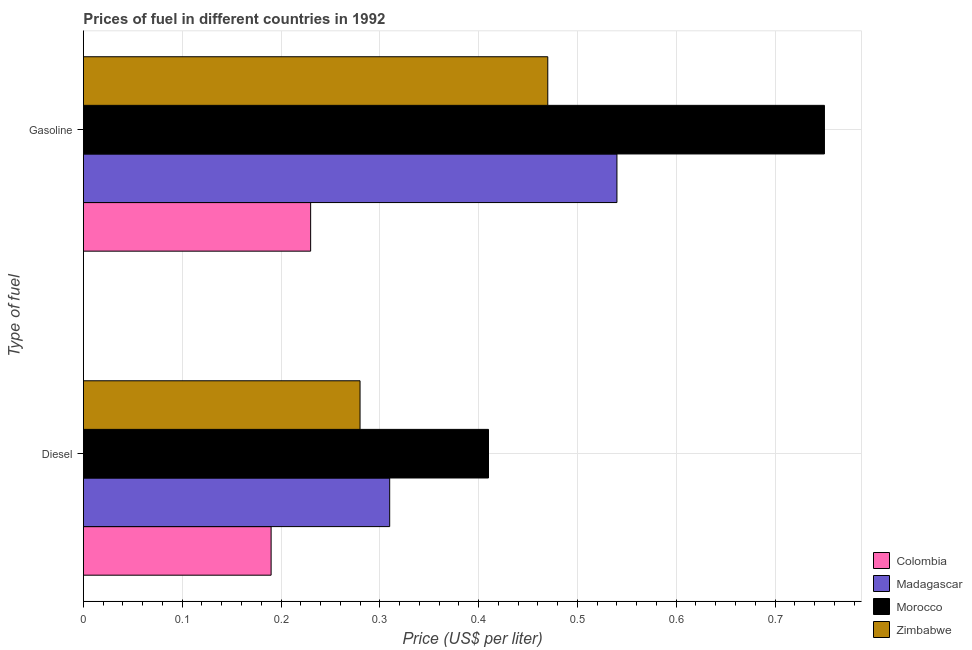How many different coloured bars are there?
Ensure brevity in your answer.  4. How many groups of bars are there?
Ensure brevity in your answer.  2. Are the number of bars per tick equal to the number of legend labels?
Your answer should be compact. Yes. Are the number of bars on each tick of the Y-axis equal?
Ensure brevity in your answer.  Yes. How many bars are there on the 2nd tick from the bottom?
Give a very brief answer. 4. What is the label of the 1st group of bars from the top?
Provide a short and direct response. Gasoline. What is the diesel price in Madagascar?
Provide a short and direct response. 0.31. Across all countries, what is the maximum diesel price?
Your response must be concise. 0.41. Across all countries, what is the minimum gasoline price?
Keep it short and to the point. 0.23. In which country was the gasoline price maximum?
Keep it short and to the point. Morocco. In which country was the diesel price minimum?
Provide a short and direct response. Colombia. What is the total diesel price in the graph?
Your response must be concise. 1.19. What is the difference between the diesel price in Zimbabwe and that in Colombia?
Offer a terse response. 0.09. What is the difference between the gasoline price in Zimbabwe and the diesel price in Madagascar?
Provide a succinct answer. 0.16. What is the average diesel price per country?
Provide a short and direct response. 0.3. What is the difference between the gasoline price and diesel price in Colombia?
Provide a succinct answer. 0.04. In how many countries, is the diesel price greater than 0.18 US$ per litre?
Ensure brevity in your answer.  4. What is the ratio of the diesel price in Colombia to that in Madagascar?
Keep it short and to the point. 0.61. Is the gasoline price in Madagascar less than that in Colombia?
Provide a short and direct response. No. What does the 3rd bar from the bottom in Diesel represents?
Ensure brevity in your answer.  Morocco. Are all the bars in the graph horizontal?
Provide a succinct answer. Yes. What is the difference between two consecutive major ticks on the X-axis?
Offer a very short reply. 0.1. Are the values on the major ticks of X-axis written in scientific E-notation?
Your answer should be very brief. No. Does the graph contain grids?
Offer a very short reply. Yes. What is the title of the graph?
Your response must be concise. Prices of fuel in different countries in 1992. Does "Togo" appear as one of the legend labels in the graph?
Your answer should be compact. No. What is the label or title of the X-axis?
Your answer should be very brief. Price (US$ per liter). What is the label or title of the Y-axis?
Your response must be concise. Type of fuel. What is the Price (US$ per liter) in Colombia in Diesel?
Keep it short and to the point. 0.19. What is the Price (US$ per liter) in Madagascar in Diesel?
Offer a very short reply. 0.31. What is the Price (US$ per liter) in Morocco in Diesel?
Give a very brief answer. 0.41. What is the Price (US$ per liter) in Zimbabwe in Diesel?
Make the answer very short. 0.28. What is the Price (US$ per liter) of Colombia in Gasoline?
Offer a terse response. 0.23. What is the Price (US$ per liter) of Madagascar in Gasoline?
Provide a succinct answer. 0.54. What is the Price (US$ per liter) in Morocco in Gasoline?
Offer a terse response. 0.75. What is the Price (US$ per liter) of Zimbabwe in Gasoline?
Offer a very short reply. 0.47. Across all Type of fuel, what is the maximum Price (US$ per liter) of Colombia?
Make the answer very short. 0.23. Across all Type of fuel, what is the maximum Price (US$ per liter) of Madagascar?
Your answer should be compact. 0.54. Across all Type of fuel, what is the maximum Price (US$ per liter) in Zimbabwe?
Offer a very short reply. 0.47. Across all Type of fuel, what is the minimum Price (US$ per liter) of Colombia?
Your answer should be compact. 0.19. Across all Type of fuel, what is the minimum Price (US$ per liter) of Madagascar?
Your answer should be very brief. 0.31. Across all Type of fuel, what is the minimum Price (US$ per liter) in Morocco?
Provide a succinct answer. 0.41. Across all Type of fuel, what is the minimum Price (US$ per liter) in Zimbabwe?
Your answer should be compact. 0.28. What is the total Price (US$ per liter) of Colombia in the graph?
Provide a succinct answer. 0.42. What is the total Price (US$ per liter) in Madagascar in the graph?
Give a very brief answer. 0.85. What is the total Price (US$ per liter) in Morocco in the graph?
Your answer should be very brief. 1.16. What is the difference between the Price (US$ per liter) of Colombia in Diesel and that in Gasoline?
Your answer should be compact. -0.04. What is the difference between the Price (US$ per liter) in Madagascar in Diesel and that in Gasoline?
Your response must be concise. -0.23. What is the difference between the Price (US$ per liter) of Morocco in Diesel and that in Gasoline?
Your response must be concise. -0.34. What is the difference between the Price (US$ per liter) of Zimbabwe in Diesel and that in Gasoline?
Provide a succinct answer. -0.19. What is the difference between the Price (US$ per liter) of Colombia in Diesel and the Price (US$ per liter) of Madagascar in Gasoline?
Your response must be concise. -0.35. What is the difference between the Price (US$ per liter) in Colombia in Diesel and the Price (US$ per liter) in Morocco in Gasoline?
Offer a terse response. -0.56. What is the difference between the Price (US$ per liter) of Colombia in Diesel and the Price (US$ per liter) of Zimbabwe in Gasoline?
Provide a succinct answer. -0.28. What is the difference between the Price (US$ per liter) in Madagascar in Diesel and the Price (US$ per liter) in Morocco in Gasoline?
Your response must be concise. -0.44. What is the difference between the Price (US$ per liter) of Madagascar in Diesel and the Price (US$ per liter) of Zimbabwe in Gasoline?
Offer a very short reply. -0.16. What is the difference between the Price (US$ per liter) of Morocco in Diesel and the Price (US$ per liter) of Zimbabwe in Gasoline?
Offer a very short reply. -0.06. What is the average Price (US$ per liter) of Colombia per Type of fuel?
Offer a very short reply. 0.21. What is the average Price (US$ per liter) of Madagascar per Type of fuel?
Keep it short and to the point. 0.42. What is the average Price (US$ per liter) of Morocco per Type of fuel?
Your answer should be compact. 0.58. What is the difference between the Price (US$ per liter) in Colombia and Price (US$ per liter) in Madagascar in Diesel?
Keep it short and to the point. -0.12. What is the difference between the Price (US$ per liter) in Colombia and Price (US$ per liter) in Morocco in Diesel?
Keep it short and to the point. -0.22. What is the difference between the Price (US$ per liter) of Colombia and Price (US$ per liter) of Zimbabwe in Diesel?
Give a very brief answer. -0.09. What is the difference between the Price (US$ per liter) of Madagascar and Price (US$ per liter) of Morocco in Diesel?
Provide a short and direct response. -0.1. What is the difference between the Price (US$ per liter) in Madagascar and Price (US$ per liter) in Zimbabwe in Diesel?
Make the answer very short. 0.03. What is the difference between the Price (US$ per liter) in Morocco and Price (US$ per liter) in Zimbabwe in Diesel?
Offer a very short reply. 0.13. What is the difference between the Price (US$ per liter) of Colombia and Price (US$ per liter) of Madagascar in Gasoline?
Ensure brevity in your answer.  -0.31. What is the difference between the Price (US$ per liter) of Colombia and Price (US$ per liter) of Morocco in Gasoline?
Provide a short and direct response. -0.52. What is the difference between the Price (US$ per liter) in Colombia and Price (US$ per liter) in Zimbabwe in Gasoline?
Provide a short and direct response. -0.24. What is the difference between the Price (US$ per liter) in Madagascar and Price (US$ per liter) in Morocco in Gasoline?
Your answer should be compact. -0.21. What is the difference between the Price (US$ per liter) in Madagascar and Price (US$ per liter) in Zimbabwe in Gasoline?
Provide a succinct answer. 0.07. What is the difference between the Price (US$ per liter) of Morocco and Price (US$ per liter) of Zimbabwe in Gasoline?
Your answer should be compact. 0.28. What is the ratio of the Price (US$ per liter) of Colombia in Diesel to that in Gasoline?
Offer a very short reply. 0.83. What is the ratio of the Price (US$ per liter) in Madagascar in Diesel to that in Gasoline?
Offer a very short reply. 0.57. What is the ratio of the Price (US$ per liter) of Morocco in Diesel to that in Gasoline?
Give a very brief answer. 0.55. What is the ratio of the Price (US$ per liter) of Zimbabwe in Diesel to that in Gasoline?
Keep it short and to the point. 0.6. What is the difference between the highest and the second highest Price (US$ per liter) of Colombia?
Offer a very short reply. 0.04. What is the difference between the highest and the second highest Price (US$ per liter) of Madagascar?
Offer a very short reply. 0.23. What is the difference between the highest and the second highest Price (US$ per liter) of Morocco?
Make the answer very short. 0.34. What is the difference between the highest and the second highest Price (US$ per liter) in Zimbabwe?
Offer a terse response. 0.19. What is the difference between the highest and the lowest Price (US$ per liter) of Colombia?
Offer a terse response. 0.04. What is the difference between the highest and the lowest Price (US$ per liter) of Madagascar?
Provide a succinct answer. 0.23. What is the difference between the highest and the lowest Price (US$ per liter) in Morocco?
Offer a terse response. 0.34. What is the difference between the highest and the lowest Price (US$ per liter) in Zimbabwe?
Provide a short and direct response. 0.19. 